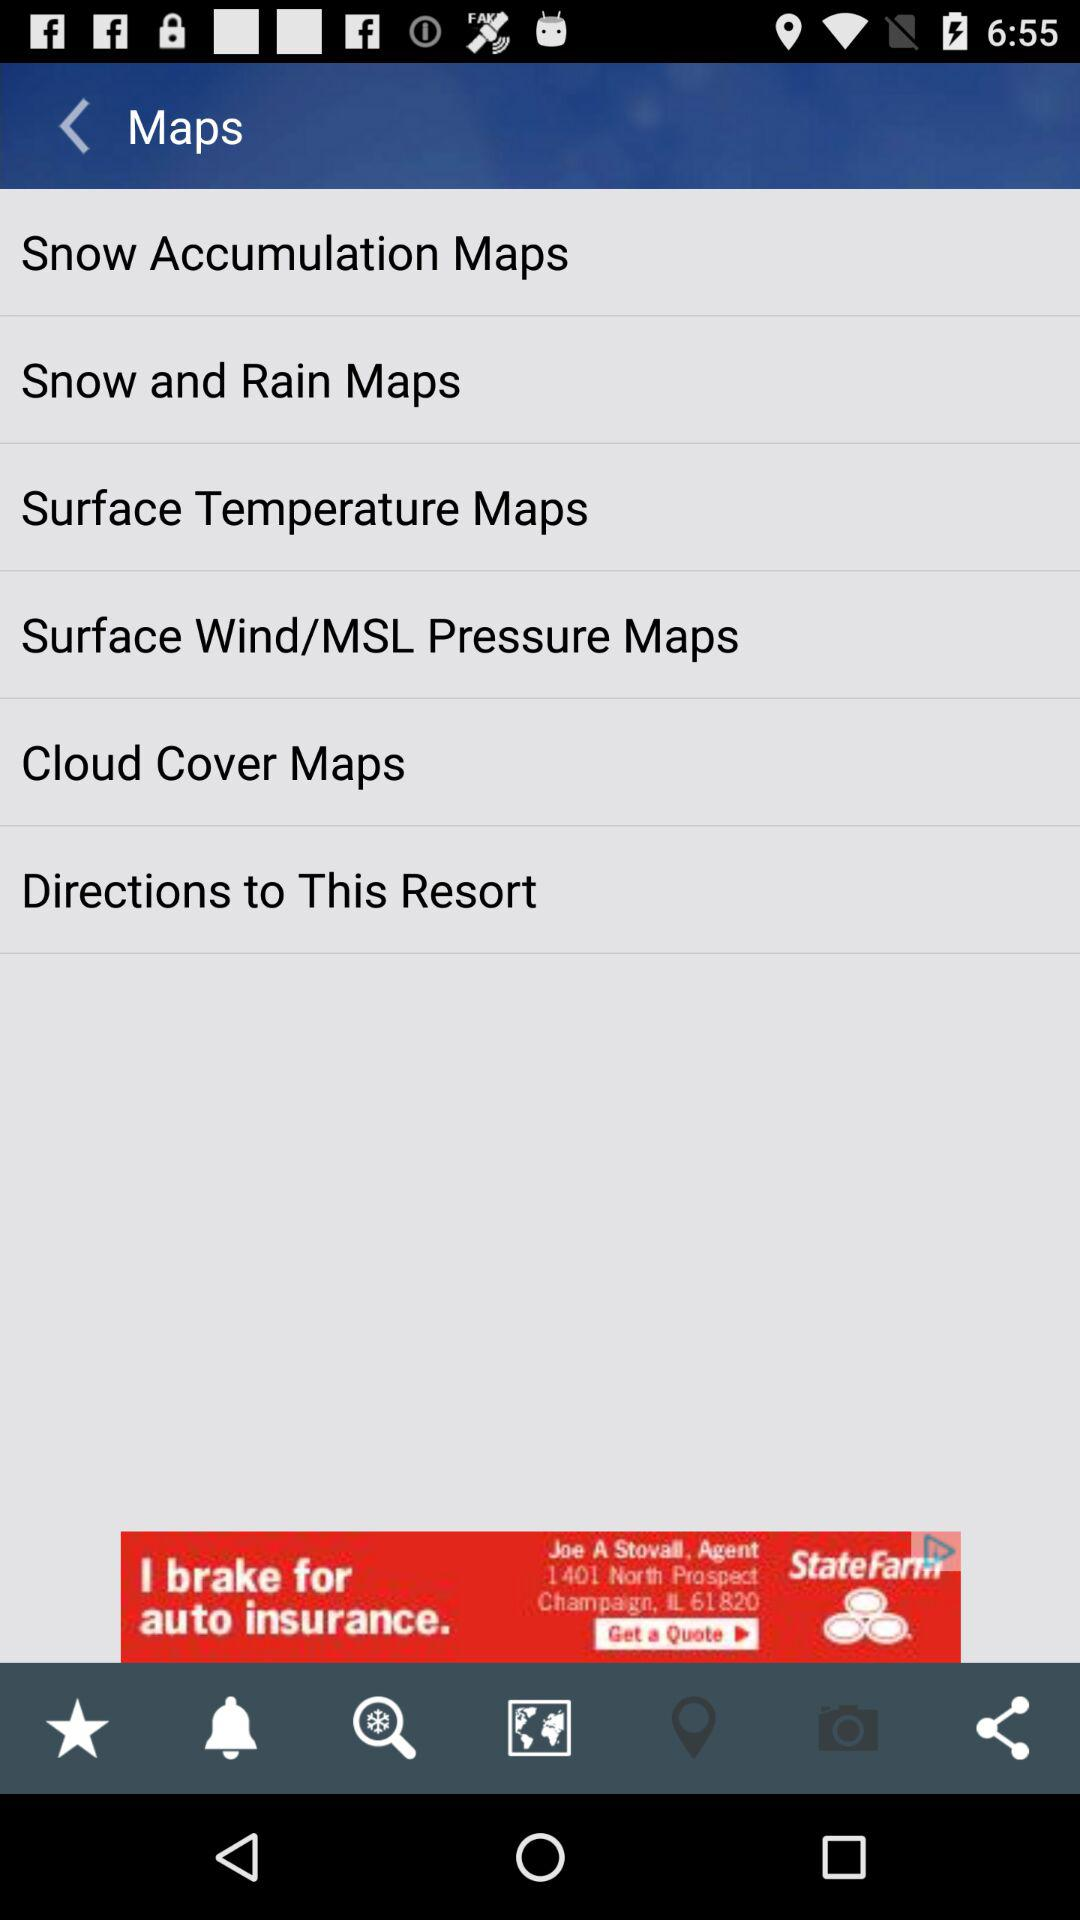How many maps are displayed on the screen?
Answer the question using a single word or phrase. 6 